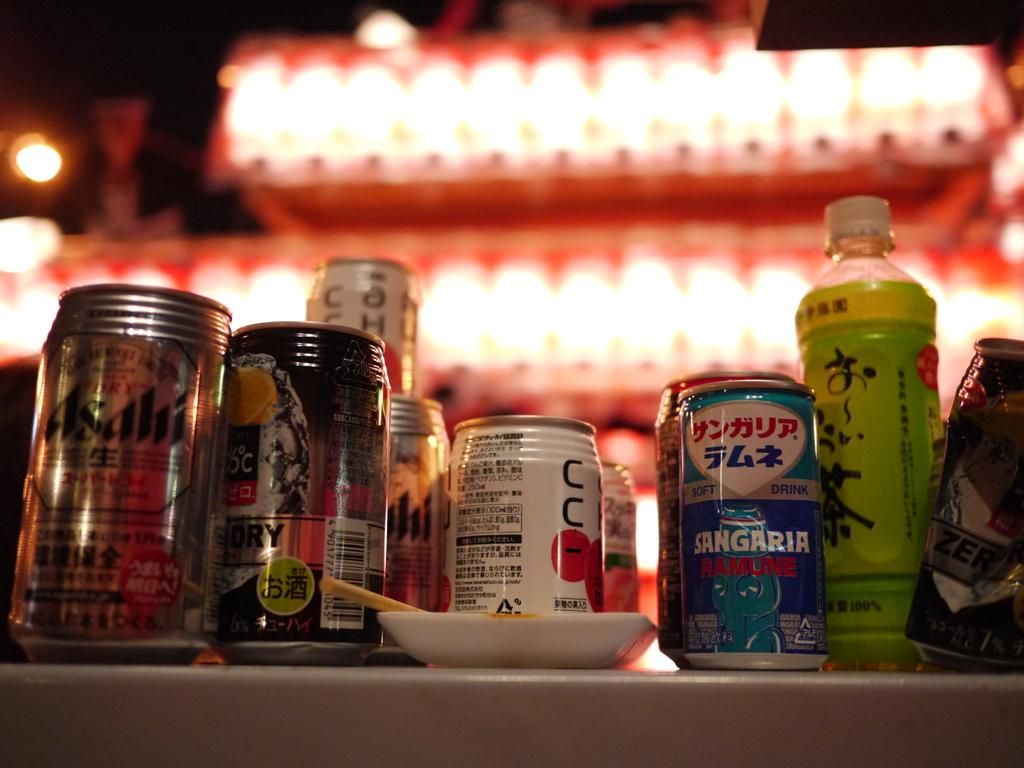Provide a one-sentence caption for the provided image. a can of sangaria sits next to several other cans and bottles. 